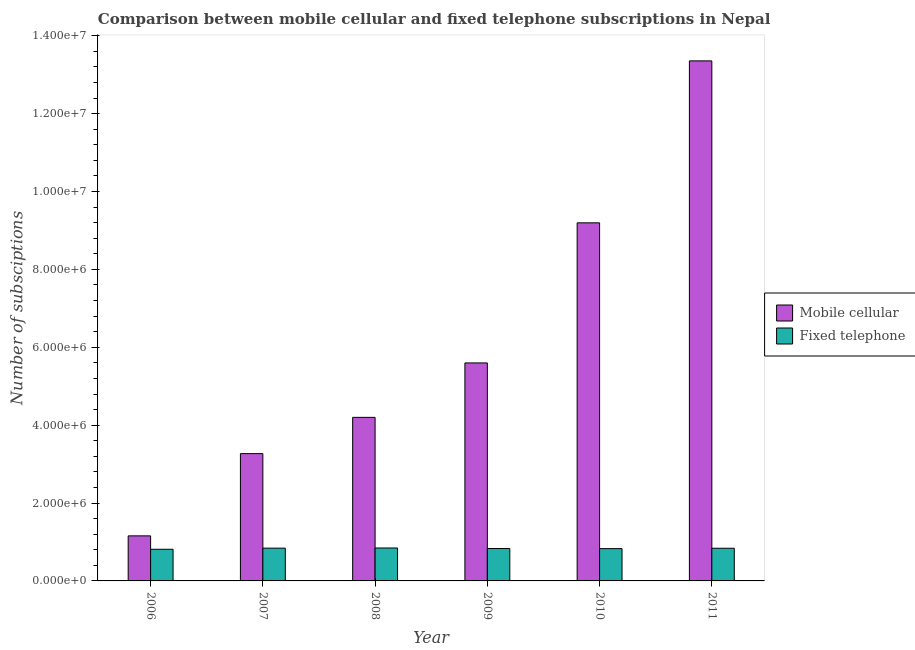How many groups of bars are there?
Offer a terse response. 6. How many bars are there on the 3rd tick from the right?
Your answer should be compact. 2. What is the label of the 6th group of bars from the left?
Provide a short and direct response. 2011. What is the number of mobile cellular subscriptions in 2009?
Your response must be concise. 5.60e+06. Across all years, what is the maximum number of mobile cellular subscriptions?
Your response must be concise. 1.34e+07. Across all years, what is the minimum number of mobile cellular subscriptions?
Offer a very short reply. 1.16e+06. What is the total number of fixed telephone subscriptions in the graph?
Ensure brevity in your answer.  5.00e+06. What is the difference between the number of mobile cellular subscriptions in 2010 and that in 2011?
Your answer should be compact. -4.16e+06. What is the difference between the number of mobile cellular subscriptions in 2011 and the number of fixed telephone subscriptions in 2006?
Your response must be concise. 1.22e+07. What is the average number of fixed telephone subscriptions per year?
Offer a terse response. 8.33e+05. In the year 2007, what is the difference between the number of fixed telephone subscriptions and number of mobile cellular subscriptions?
Ensure brevity in your answer.  0. In how many years, is the number of mobile cellular subscriptions greater than 7600000?
Provide a succinct answer. 2. What is the ratio of the number of fixed telephone subscriptions in 2010 to that in 2011?
Offer a very short reply. 0.99. Is the number of fixed telephone subscriptions in 2006 less than that in 2009?
Make the answer very short. Yes. What is the difference between the highest and the second highest number of mobile cellular subscriptions?
Ensure brevity in your answer.  4.16e+06. What is the difference between the highest and the lowest number of fixed telephone subscriptions?
Provide a short and direct response. 3.29e+04. What does the 2nd bar from the left in 2007 represents?
Provide a short and direct response. Fixed telephone. What does the 2nd bar from the right in 2010 represents?
Keep it short and to the point. Mobile cellular. Are all the bars in the graph horizontal?
Your response must be concise. No. How many years are there in the graph?
Give a very brief answer. 6. What is the difference between two consecutive major ticks on the Y-axis?
Provide a short and direct response. 2.00e+06. Are the values on the major ticks of Y-axis written in scientific E-notation?
Provide a succinct answer. Yes. Does the graph contain grids?
Provide a succinct answer. No. How are the legend labels stacked?
Provide a short and direct response. Vertical. What is the title of the graph?
Provide a succinct answer. Comparison between mobile cellular and fixed telephone subscriptions in Nepal. What is the label or title of the X-axis?
Your answer should be very brief. Year. What is the label or title of the Y-axis?
Provide a short and direct response. Number of subsciptions. What is the Number of subsciptions of Mobile cellular in 2006?
Provide a succinct answer. 1.16e+06. What is the Number of subsciptions of Fixed telephone in 2006?
Give a very brief answer. 8.13e+05. What is the Number of subsciptions of Mobile cellular in 2007?
Provide a succinct answer. 3.27e+06. What is the Number of subsciptions in Fixed telephone in 2007?
Offer a terse response. 8.42e+05. What is the Number of subsciptions of Mobile cellular in 2008?
Keep it short and to the point. 4.20e+06. What is the Number of subsciptions of Fixed telephone in 2008?
Ensure brevity in your answer.  8.46e+05. What is the Number of subsciptions in Mobile cellular in 2009?
Provide a short and direct response. 5.60e+06. What is the Number of subsciptions of Fixed telephone in 2009?
Provide a short and direct response. 8.32e+05. What is the Number of subsciptions in Mobile cellular in 2010?
Ensure brevity in your answer.  9.20e+06. What is the Number of subsciptions of Fixed telephone in 2010?
Your answer should be very brief. 8.29e+05. What is the Number of subsciptions in Mobile cellular in 2011?
Give a very brief answer. 1.34e+07. What is the Number of subsciptions in Fixed telephone in 2011?
Offer a terse response. 8.39e+05. Across all years, what is the maximum Number of subsciptions of Mobile cellular?
Your answer should be compact. 1.34e+07. Across all years, what is the maximum Number of subsciptions in Fixed telephone?
Ensure brevity in your answer.  8.46e+05. Across all years, what is the minimum Number of subsciptions in Mobile cellular?
Your response must be concise. 1.16e+06. Across all years, what is the minimum Number of subsciptions in Fixed telephone?
Give a very brief answer. 8.13e+05. What is the total Number of subsciptions of Mobile cellular in the graph?
Give a very brief answer. 3.68e+07. What is the total Number of subsciptions of Fixed telephone in the graph?
Your answer should be very brief. 5.00e+06. What is the difference between the Number of subsciptions in Mobile cellular in 2006 and that in 2007?
Give a very brief answer. -2.11e+06. What is the difference between the Number of subsciptions in Fixed telephone in 2006 and that in 2007?
Give a very brief answer. -2.91e+04. What is the difference between the Number of subsciptions of Mobile cellular in 2006 and that in 2008?
Your answer should be very brief. -3.04e+06. What is the difference between the Number of subsciptions in Fixed telephone in 2006 and that in 2008?
Make the answer very short. -3.29e+04. What is the difference between the Number of subsciptions in Mobile cellular in 2006 and that in 2009?
Your answer should be very brief. -4.44e+06. What is the difference between the Number of subsciptions of Fixed telephone in 2006 and that in 2009?
Offer a very short reply. -1.91e+04. What is the difference between the Number of subsciptions in Mobile cellular in 2006 and that in 2010?
Provide a short and direct response. -8.04e+06. What is the difference between the Number of subsciptions in Fixed telephone in 2006 and that in 2010?
Your answer should be compact. -1.65e+04. What is the difference between the Number of subsciptions in Mobile cellular in 2006 and that in 2011?
Ensure brevity in your answer.  -1.22e+07. What is the difference between the Number of subsciptions of Fixed telephone in 2006 and that in 2011?
Make the answer very short. -2.63e+04. What is the difference between the Number of subsciptions of Mobile cellular in 2007 and that in 2008?
Give a very brief answer. -9.31e+05. What is the difference between the Number of subsciptions in Fixed telephone in 2007 and that in 2008?
Make the answer very short. -3844. What is the difference between the Number of subsciptions in Mobile cellular in 2007 and that in 2009?
Provide a succinct answer. -2.33e+06. What is the difference between the Number of subsciptions of Fixed telephone in 2007 and that in 2009?
Give a very brief answer. 9995. What is the difference between the Number of subsciptions in Mobile cellular in 2007 and that in 2010?
Ensure brevity in your answer.  -5.93e+06. What is the difference between the Number of subsciptions of Fixed telephone in 2007 and that in 2010?
Offer a terse response. 1.26e+04. What is the difference between the Number of subsciptions of Mobile cellular in 2007 and that in 2011?
Offer a very short reply. -1.01e+07. What is the difference between the Number of subsciptions of Fixed telephone in 2007 and that in 2011?
Offer a very short reply. 2798. What is the difference between the Number of subsciptions of Mobile cellular in 2008 and that in 2009?
Your response must be concise. -1.40e+06. What is the difference between the Number of subsciptions of Fixed telephone in 2008 and that in 2009?
Make the answer very short. 1.38e+04. What is the difference between the Number of subsciptions of Mobile cellular in 2008 and that in 2010?
Your answer should be compact. -5.00e+06. What is the difference between the Number of subsciptions of Fixed telephone in 2008 and that in 2010?
Give a very brief answer. 1.64e+04. What is the difference between the Number of subsciptions of Mobile cellular in 2008 and that in 2011?
Make the answer very short. -9.15e+06. What is the difference between the Number of subsciptions of Fixed telephone in 2008 and that in 2011?
Make the answer very short. 6642. What is the difference between the Number of subsciptions of Mobile cellular in 2009 and that in 2010?
Provide a succinct answer. -3.60e+06. What is the difference between the Number of subsciptions of Fixed telephone in 2009 and that in 2010?
Provide a succinct answer. 2606. What is the difference between the Number of subsciptions in Mobile cellular in 2009 and that in 2011?
Keep it short and to the point. -7.76e+06. What is the difference between the Number of subsciptions in Fixed telephone in 2009 and that in 2011?
Offer a terse response. -7197. What is the difference between the Number of subsciptions of Mobile cellular in 2010 and that in 2011?
Give a very brief answer. -4.16e+06. What is the difference between the Number of subsciptions in Fixed telephone in 2010 and that in 2011?
Ensure brevity in your answer.  -9803. What is the difference between the Number of subsciptions in Mobile cellular in 2006 and the Number of subsciptions in Fixed telephone in 2007?
Your answer should be compact. 3.15e+05. What is the difference between the Number of subsciptions in Mobile cellular in 2006 and the Number of subsciptions in Fixed telephone in 2008?
Your answer should be compact. 3.12e+05. What is the difference between the Number of subsciptions in Mobile cellular in 2006 and the Number of subsciptions in Fixed telephone in 2009?
Provide a short and direct response. 3.25e+05. What is the difference between the Number of subsciptions in Mobile cellular in 2006 and the Number of subsciptions in Fixed telephone in 2010?
Provide a short and direct response. 3.28e+05. What is the difference between the Number of subsciptions of Mobile cellular in 2006 and the Number of subsciptions of Fixed telephone in 2011?
Offer a terse response. 3.18e+05. What is the difference between the Number of subsciptions of Mobile cellular in 2007 and the Number of subsciptions of Fixed telephone in 2008?
Give a very brief answer. 2.42e+06. What is the difference between the Number of subsciptions of Mobile cellular in 2007 and the Number of subsciptions of Fixed telephone in 2009?
Provide a succinct answer. 2.44e+06. What is the difference between the Number of subsciptions of Mobile cellular in 2007 and the Number of subsciptions of Fixed telephone in 2010?
Ensure brevity in your answer.  2.44e+06. What is the difference between the Number of subsciptions of Mobile cellular in 2007 and the Number of subsciptions of Fixed telephone in 2011?
Give a very brief answer. 2.43e+06. What is the difference between the Number of subsciptions in Mobile cellular in 2008 and the Number of subsciptions in Fixed telephone in 2009?
Make the answer very short. 3.37e+06. What is the difference between the Number of subsciptions in Mobile cellular in 2008 and the Number of subsciptions in Fixed telephone in 2010?
Offer a very short reply. 3.37e+06. What is the difference between the Number of subsciptions in Mobile cellular in 2008 and the Number of subsciptions in Fixed telephone in 2011?
Offer a very short reply. 3.36e+06. What is the difference between the Number of subsciptions in Mobile cellular in 2009 and the Number of subsciptions in Fixed telephone in 2010?
Give a very brief answer. 4.77e+06. What is the difference between the Number of subsciptions in Mobile cellular in 2009 and the Number of subsciptions in Fixed telephone in 2011?
Make the answer very short. 4.76e+06. What is the difference between the Number of subsciptions of Mobile cellular in 2010 and the Number of subsciptions of Fixed telephone in 2011?
Your response must be concise. 8.36e+06. What is the average Number of subsciptions of Mobile cellular per year?
Keep it short and to the point. 6.13e+06. What is the average Number of subsciptions in Fixed telephone per year?
Offer a very short reply. 8.33e+05. In the year 2006, what is the difference between the Number of subsciptions of Mobile cellular and Number of subsciptions of Fixed telephone?
Ensure brevity in your answer.  3.44e+05. In the year 2007, what is the difference between the Number of subsciptions in Mobile cellular and Number of subsciptions in Fixed telephone?
Ensure brevity in your answer.  2.43e+06. In the year 2008, what is the difference between the Number of subsciptions in Mobile cellular and Number of subsciptions in Fixed telephone?
Your response must be concise. 3.35e+06. In the year 2009, what is the difference between the Number of subsciptions of Mobile cellular and Number of subsciptions of Fixed telephone?
Give a very brief answer. 4.77e+06. In the year 2010, what is the difference between the Number of subsciptions in Mobile cellular and Number of subsciptions in Fixed telephone?
Ensure brevity in your answer.  8.37e+06. In the year 2011, what is the difference between the Number of subsciptions in Mobile cellular and Number of subsciptions in Fixed telephone?
Keep it short and to the point. 1.25e+07. What is the ratio of the Number of subsciptions in Mobile cellular in 2006 to that in 2007?
Give a very brief answer. 0.35. What is the ratio of the Number of subsciptions in Fixed telephone in 2006 to that in 2007?
Your response must be concise. 0.97. What is the ratio of the Number of subsciptions of Mobile cellular in 2006 to that in 2008?
Ensure brevity in your answer.  0.28. What is the ratio of the Number of subsciptions of Fixed telephone in 2006 to that in 2008?
Ensure brevity in your answer.  0.96. What is the ratio of the Number of subsciptions in Mobile cellular in 2006 to that in 2009?
Provide a succinct answer. 0.21. What is the ratio of the Number of subsciptions of Mobile cellular in 2006 to that in 2010?
Provide a short and direct response. 0.13. What is the ratio of the Number of subsciptions of Fixed telephone in 2006 to that in 2010?
Ensure brevity in your answer.  0.98. What is the ratio of the Number of subsciptions of Mobile cellular in 2006 to that in 2011?
Offer a very short reply. 0.09. What is the ratio of the Number of subsciptions of Fixed telephone in 2006 to that in 2011?
Ensure brevity in your answer.  0.97. What is the ratio of the Number of subsciptions in Mobile cellular in 2007 to that in 2008?
Provide a succinct answer. 0.78. What is the ratio of the Number of subsciptions of Mobile cellular in 2007 to that in 2009?
Your answer should be compact. 0.58. What is the ratio of the Number of subsciptions of Fixed telephone in 2007 to that in 2009?
Offer a terse response. 1.01. What is the ratio of the Number of subsciptions in Mobile cellular in 2007 to that in 2010?
Give a very brief answer. 0.36. What is the ratio of the Number of subsciptions in Fixed telephone in 2007 to that in 2010?
Provide a short and direct response. 1.02. What is the ratio of the Number of subsciptions of Mobile cellular in 2007 to that in 2011?
Offer a very short reply. 0.24. What is the ratio of the Number of subsciptions in Mobile cellular in 2008 to that in 2009?
Your response must be concise. 0.75. What is the ratio of the Number of subsciptions of Fixed telephone in 2008 to that in 2009?
Your answer should be compact. 1.02. What is the ratio of the Number of subsciptions in Mobile cellular in 2008 to that in 2010?
Offer a very short reply. 0.46. What is the ratio of the Number of subsciptions in Fixed telephone in 2008 to that in 2010?
Ensure brevity in your answer.  1.02. What is the ratio of the Number of subsciptions in Mobile cellular in 2008 to that in 2011?
Offer a terse response. 0.31. What is the ratio of the Number of subsciptions of Fixed telephone in 2008 to that in 2011?
Keep it short and to the point. 1.01. What is the ratio of the Number of subsciptions of Mobile cellular in 2009 to that in 2010?
Keep it short and to the point. 0.61. What is the ratio of the Number of subsciptions in Fixed telephone in 2009 to that in 2010?
Your answer should be compact. 1. What is the ratio of the Number of subsciptions in Mobile cellular in 2009 to that in 2011?
Your response must be concise. 0.42. What is the ratio of the Number of subsciptions of Fixed telephone in 2009 to that in 2011?
Give a very brief answer. 0.99. What is the ratio of the Number of subsciptions in Mobile cellular in 2010 to that in 2011?
Your answer should be compact. 0.69. What is the ratio of the Number of subsciptions in Fixed telephone in 2010 to that in 2011?
Offer a terse response. 0.99. What is the difference between the highest and the second highest Number of subsciptions in Mobile cellular?
Give a very brief answer. 4.16e+06. What is the difference between the highest and the second highest Number of subsciptions in Fixed telephone?
Make the answer very short. 3844. What is the difference between the highest and the lowest Number of subsciptions in Mobile cellular?
Keep it short and to the point. 1.22e+07. What is the difference between the highest and the lowest Number of subsciptions of Fixed telephone?
Your answer should be very brief. 3.29e+04. 